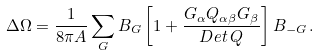<formula> <loc_0><loc_0><loc_500><loc_500>\Delta \Omega = \frac { 1 } { 8 \pi A } \sum _ { G } B _ { G } \left [ 1 + \frac { G _ { \alpha } Q _ { \alpha \beta } G _ { \beta } } { D e t \, Q } \right ] B _ { - { G } } \, .</formula> 